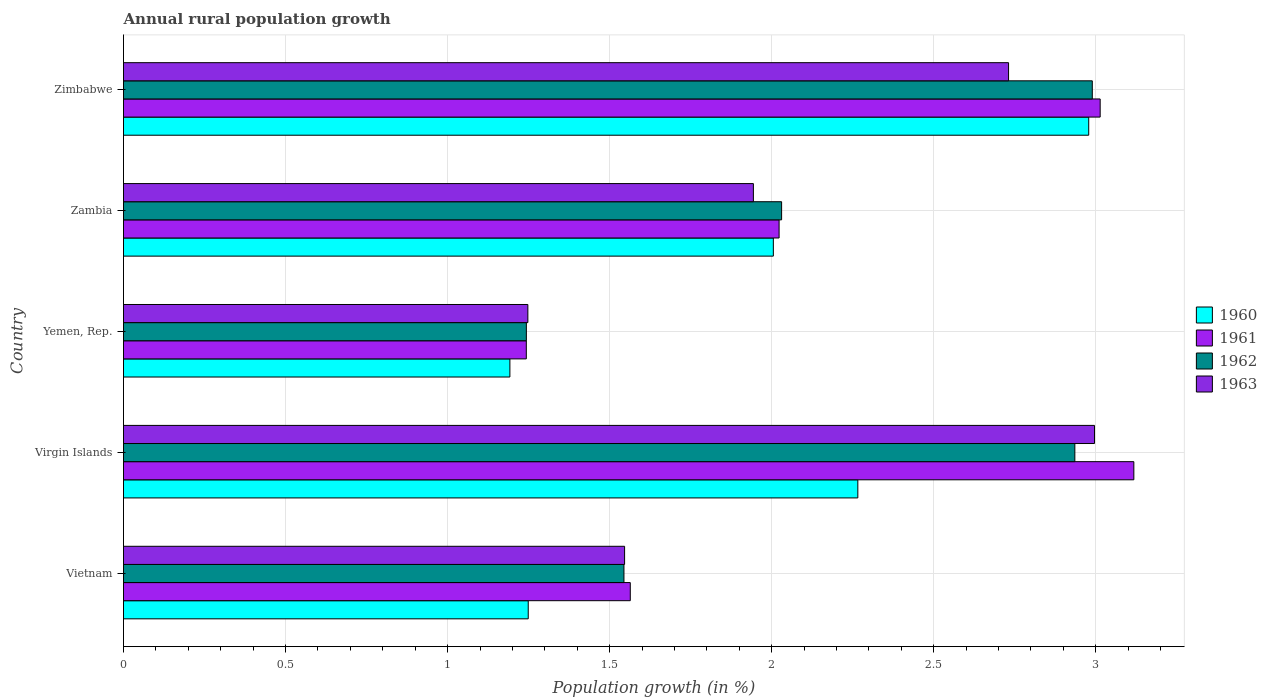How many groups of bars are there?
Provide a succinct answer. 5. Are the number of bars per tick equal to the number of legend labels?
Your answer should be very brief. Yes. Are the number of bars on each tick of the Y-axis equal?
Ensure brevity in your answer.  Yes. What is the label of the 2nd group of bars from the top?
Offer a terse response. Zambia. In how many cases, is the number of bars for a given country not equal to the number of legend labels?
Keep it short and to the point. 0. What is the percentage of rural population growth in 1961 in Zambia?
Offer a very short reply. 2.02. Across all countries, what is the maximum percentage of rural population growth in 1963?
Ensure brevity in your answer.  3. Across all countries, what is the minimum percentage of rural population growth in 1962?
Provide a succinct answer. 1.24. In which country was the percentage of rural population growth in 1962 maximum?
Ensure brevity in your answer.  Zimbabwe. In which country was the percentage of rural population growth in 1963 minimum?
Your answer should be compact. Yemen, Rep. What is the total percentage of rural population growth in 1962 in the graph?
Your answer should be compact. 10.74. What is the difference between the percentage of rural population growth in 1961 in Vietnam and that in Virgin Islands?
Give a very brief answer. -1.55. What is the difference between the percentage of rural population growth in 1960 in Yemen, Rep. and the percentage of rural population growth in 1961 in Zimbabwe?
Your response must be concise. -1.82. What is the average percentage of rural population growth in 1963 per country?
Provide a succinct answer. 2.09. What is the difference between the percentage of rural population growth in 1962 and percentage of rural population growth in 1960 in Yemen, Rep.?
Offer a terse response. 0.05. In how many countries, is the percentage of rural population growth in 1961 greater than 3.1 %?
Your answer should be very brief. 1. What is the ratio of the percentage of rural population growth in 1962 in Vietnam to that in Yemen, Rep.?
Offer a terse response. 1.24. Is the percentage of rural population growth in 1961 in Vietnam less than that in Zimbabwe?
Provide a short and direct response. Yes. What is the difference between the highest and the second highest percentage of rural population growth in 1960?
Give a very brief answer. 0.71. What is the difference between the highest and the lowest percentage of rural population growth in 1963?
Keep it short and to the point. 1.75. Is it the case that in every country, the sum of the percentage of rural population growth in 1960 and percentage of rural population growth in 1962 is greater than the sum of percentage of rural population growth in 1961 and percentage of rural population growth in 1963?
Offer a terse response. No. What does the 3rd bar from the top in Vietnam represents?
Your answer should be very brief. 1961. What does the 3rd bar from the bottom in Vietnam represents?
Ensure brevity in your answer.  1962. Is it the case that in every country, the sum of the percentage of rural population growth in 1962 and percentage of rural population growth in 1963 is greater than the percentage of rural population growth in 1961?
Your answer should be very brief. Yes. How many bars are there?
Offer a terse response. 20. How many countries are there in the graph?
Your answer should be compact. 5. Does the graph contain any zero values?
Your answer should be very brief. No. Does the graph contain grids?
Provide a succinct answer. Yes. How are the legend labels stacked?
Ensure brevity in your answer.  Vertical. What is the title of the graph?
Offer a terse response. Annual rural population growth. What is the label or title of the X-axis?
Keep it short and to the point. Population growth (in %). What is the Population growth (in %) in 1960 in Vietnam?
Make the answer very short. 1.25. What is the Population growth (in %) in 1961 in Vietnam?
Keep it short and to the point. 1.56. What is the Population growth (in %) in 1962 in Vietnam?
Make the answer very short. 1.54. What is the Population growth (in %) in 1963 in Vietnam?
Your answer should be very brief. 1.55. What is the Population growth (in %) in 1960 in Virgin Islands?
Your response must be concise. 2.27. What is the Population growth (in %) of 1961 in Virgin Islands?
Provide a short and direct response. 3.12. What is the Population growth (in %) in 1962 in Virgin Islands?
Your answer should be compact. 2.94. What is the Population growth (in %) of 1963 in Virgin Islands?
Ensure brevity in your answer.  3. What is the Population growth (in %) of 1960 in Yemen, Rep.?
Ensure brevity in your answer.  1.19. What is the Population growth (in %) in 1961 in Yemen, Rep.?
Your answer should be compact. 1.24. What is the Population growth (in %) in 1962 in Yemen, Rep.?
Ensure brevity in your answer.  1.24. What is the Population growth (in %) of 1963 in Yemen, Rep.?
Your answer should be compact. 1.25. What is the Population growth (in %) in 1960 in Zambia?
Provide a succinct answer. 2.01. What is the Population growth (in %) in 1961 in Zambia?
Offer a very short reply. 2.02. What is the Population growth (in %) in 1962 in Zambia?
Ensure brevity in your answer.  2.03. What is the Population growth (in %) in 1963 in Zambia?
Ensure brevity in your answer.  1.94. What is the Population growth (in %) of 1960 in Zimbabwe?
Give a very brief answer. 2.98. What is the Population growth (in %) in 1961 in Zimbabwe?
Offer a very short reply. 3.01. What is the Population growth (in %) in 1962 in Zimbabwe?
Keep it short and to the point. 2.99. What is the Population growth (in %) in 1963 in Zimbabwe?
Your answer should be compact. 2.73. Across all countries, what is the maximum Population growth (in %) of 1960?
Offer a very short reply. 2.98. Across all countries, what is the maximum Population growth (in %) of 1961?
Provide a succinct answer. 3.12. Across all countries, what is the maximum Population growth (in %) in 1962?
Provide a succinct answer. 2.99. Across all countries, what is the maximum Population growth (in %) of 1963?
Provide a short and direct response. 3. Across all countries, what is the minimum Population growth (in %) of 1960?
Your answer should be compact. 1.19. Across all countries, what is the minimum Population growth (in %) of 1961?
Your answer should be very brief. 1.24. Across all countries, what is the minimum Population growth (in %) in 1962?
Make the answer very short. 1.24. Across all countries, what is the minimum Population growth (in %) of 1963?
Make the answer very short. 1.25. What is the total Population growth (in %) in 1960 in the graph?
Offer a terse response. 9.69. What is the total Population growth (in %) in 1961 in the graph?
Provide a short and direct response. 10.96. What is the total Population growth (in %) of 1962 in the graph?
Make the answer very short. 10.74. What is the total Population growth (in %) in 1963 in the graph?
Make the answer very short. 10.46. What is the difference between the Population growth (in %) of 1960 in Vietnam and that in Virgin Islands?
Make the answer very short. -1.02. What is the difference between the Population growth (in %) of 1961 in Vietnam and that in Virgin Islands?
Provide a succinct answer. -1.55. What is the difference between the Population growth (in %) in 1962 in Vietnam and that in Virgin Islands?
Your response must be concise. -1.39. What is the difference between the Population growth (in %) of 1963 in Vietnam and that in Virgin Islands?
Provide a short and direct response. -1.45. What is the difference between the Population growth (in %) in 1960 in Vietnam and that in Yemen, Rep.?
Your response must be concise. 0.06. What is the difference between the Population growth (in %) of 1961 in Vietnam and that in Yemen, Rep.?
Offer a very short reply. 0.32. What is the difference between the Population growth (in %) in 1962 in Vietnam and that in Yemen, Rep.?
Keep it short and to the point. 0.3. What is the difference between the Population growth (in %) of 1963 in Vietnam and that in Yemen, Rep.?
Your answer should be compact. 0.3. What is the difference between the Population growth (in %) in 1960 in Vietnam and that in Zambia?
Ensure brevity in your answer.  -0.76. What is the difference between the Population growth (in %) in 1961 in Vietnam and that in Zambia?
Ensure brevity in your answer.  -0.46. What is the difference between the Population growth (in %) in 1962 in Vietnam and that in Zambia?
Give a very brief answer. -0.49. What is the difference between the Population growth (in %) of 1963 in Vietnam and that in Zambia?
Your response must be concise. -0.4. What is the difference between the Population growth (in %) in 1960 in Vietnam and that in Zimbabwe?
Provide a succinct answer. -1.73. What is the difference between the Population growth (in %) in 1961 in Vietnam and that in Zimbabwe?
Your response must be concise. -1.45. What is the difference between the Population growth (in %) of 1962 in Vietnam and that in Zimbabwe?
Ensure brevity in your answer.  -1.45. What is the difference between the Population growth (in %) of 1963 in Vietnam and that in Zimbabwe?
Your answer should be compact. -1.18. What is the difference between the Population growth (in %) in 1960 in Virgin Islands and that in Yemen, Rep.?
Provide a succinct answer. 1.07. What is the difference between the Population growth (in %) in 1961 in Virgin Islands and that in Yemen, Rep.?
Provide a short and direct response. 1.87. What is the difference between the Population growth (in %) in 1962 in Virgin Islands and that in Yemen, Rep.?
Your answer should be compact. 1.69. What is the difference between the Population growth (in %) of 1963 in Virgin Islands and that in Yemen, Rep.?
Keep it short and to the point. 1.75. What is the difference between the Population growth (in %) in 1960 in Virgin Islands and that in Zambia?
Ensure brevity in your answer.  0.26. What is the difference between the Population growth (in %) of 1961 in Virgin Islands and that in Zambia?
Your answer should be compact. 1.09. What is the difference between the Population growth (in %) of 1962 in Virgin Islands and that in Zambia?
Your answer should be compact. 0.9. What is the difference between the Population growth (in %) of 1963 in Virgin Islands and that in Zambia?
Your answer should be very brief. 1.05. What is the difference between the Population growth (in %) in 1960 in Virgin Islands and that in Zimbabwe?
Offer a terse response. -0.71. What is the difference between the Population growth (in %) in 1961 in Virgin Islands and that in Zimbabwe?
Give a very brief answer. 0.1. What is the difference between the Population growth (in %) in 1962 in Virgin Islands and that in Zimbabwe?
Make the answer very short. -0.05. What is the difference between the Population growth (in %) in 1963 in Virgin Islands and that in Zimbabwe?
Give a very brief answer. 0.27. What is the difference between the Population growth (in %) in 1960 in Yemen, Rep. and that in Zambia?
Give a very brief answer. -0.81. What is the difference between the Population growth (in %) in 1961 in Yemen, Rep. and that in Zambia?
Offer a very short reply. -0.78. What is the difference between the Population growth (in %) in 1962 in Yemen, Rep. and that in Zambia?
Give a very brief answer. -0.79. What is the difference between the Population growth (in %) of 1963 in Yemen, Rep. and that in Zambia?
Your answer should be very brief. -0.7. What is the difference between the Population growth (in %) of 1960 in Yemen, Rep. and that in Zimbabwe?
Your answer should be very brief. -1.79. What is the difference between the Population growth (in %) of 1961 in Yemen, Rep. and that in Zimbabwe?
Offer a terse response. -1.77. What is the difference between the Population growth (in %) of 1962 in Yemen, Rep. and that in Zimbabwe?
Your response must be concise. -1.75. What is the difference between the Population growth (in %) of 1963 in Yemen, Rep. and that in Zimbabwe?
Ensure brevity in your answer.  -1.48. What is the difference between the Population growth (in %) of 1960 in Zambia and that in Zimbabwe?
Your answer should be compact. -0.97. What is the difference between the Population growth (in %) of 1961 in Zambia and that in Zimbabwe?
Make the answer very short. -0.99. What is the difference between the Population growth (in %) of 1962 in Zambia and that in Zimbabwe?
Make the answer very short. -0.96. What is the difference between the Population growth (in %) of 1963 in Zambia and that in Zimbabwe?
Your response must be concise. -0.79. What is the difference between the Population growth (in %) in 1960 in Vietnam and the Population growth (in %) in 1961 in Virgin Islands?
Make the answer very short. -1.87. What is the difference between the Population growth (in %) of 1960 in Vietnam and the Population growth (in %) of 1962 in Virgin Islands?
Your response must be concise. -1.69. What is the difference between the Population growth (in %) of 1960 in Vietnam and the Population growth (in %) of 1963 in Virgin Islands?
Give a very brief answer. -1.75. What is the difference between the Population growth (in %) of 1961 in Vietnam and the Population growth (in %) of 1962 in Virgin Islands?
Provide a succinct answer. -1.37. What is the difference between the Population growth (in %) of 1961 in Vietnam and the Population growth (in %) of 1963 in Virgin Islands?
Offer a very short reply. -1.43. What is the difference between the Population growth (in %) in 1962 in Vietnam and the Population growth (in %) in 1963 in Virgin Islands?
Provide a short and direct response. -1.45. What is the difference between the Population growth (in %) of 1960 in Vietnam and the Population growth (in %) of 1961 in Yemen, Rep.?
Your answer should be compact. 0.01. What is the difference between the Population growth (in %) in 1960 in Vietnam and the Population growth (in %) in 1962 in Yemen, Rep.?
Provide a succinct answer. 0.01. What is the difference between the Population growth (in %) of 1960 in Vietnam and the Population growth (in %) of 1963 in Yemen, Rep.?
Your answer should be very brief. 0. What is the difference between the Population growth (in %) in 1961 in Vietnam and the Population growth (in %) in 1962 in Yemen, Rep.?
Give a very brief answer. 0.32. What is the difference between the Population growth (in %) of 1961 in Vietnam and the Population growth (in %) of 1963 in Yemen, Rep.?
Your answer should be compact. 0.32. What is the difference between the Population growth (in %) of 1962 in Vietnam and the Population growth (in %) of 1963 in Yemen, Rep.?
Your response must be concise. 0.3. What is the difference between the Population growth (in %) in 1960 in Vietnam and the Population growth (in %) in 1961 in Zambia?
Provide a short and direct response. -0.77. What is the difference between the Population growth (in %) of 1960 in Vietnam and the Population growth (in %) of 1962 in Zambia?
Provide a short and direct response. -0.78. What is the difference between the Population growth (in %) of 1960 in Vietnam and the Population growth (in %) of 1963 in Zambia?
Your response must be concise. -0.69. What is the difference between the Population growth (in %) in 1961 in Vietnam and the Population growth (in %) in 1962 in Zambia?
Offer a terse response. -0.47. What is the difference between the Population growth (in %) in 1961 in Vietnam and the Population growth (in %) in 1963 in Zambia?
Your answer should be very brief. -0.38. What is the difference between the Population growth (in %) in 1962 in Vietnam and the Population growth (in %) in 1963 in Zambia?
Your answer should be very brief. -0.4. What is the difference between the Population growth (in %) of 1960 in Vietnam and the Population growth (in %) of 1961 in Zimbabwe?
Provide a succinct answer. -1.76. What is the difference between the Population growth (in %) in 1960 in Vietnam and the Population growth (in %) in 1962 in Zimbabwe?
Offer a terse response. -1.74. What is the difference between the Population growth (in %) of 1960 in Vietnam and the Population growth (in %) of 1963 in Zimbabwe?
Provide a succinct answer. -1.48. What is the difference between the Population growth (in %) of 1961 in Vietnam and the Population growth (in %) of 1962 in Zimbabwe?
Keep it short and to the point. -1.43. What is the difference between the Population growth (in %) of 1961 in Vietnam and the Population growth (in %) of 1963 in Zimbabwe?
Your answer should be compact. -1.17. What is the difference between the Population growth (in %) in 1962 in Vietnam and the Population growth (in %) in 1963 in Zimbabwe?
Ensure brevity in your answer.  -1.19. What is the difference between the Population growth (in %) in 1960 in Virgin Islands and the Population growth (in %) in 1961 in Yemen, Rep.?
Ensure brevity in your answer.  1.02. What is the difference between the Population growth (in %) in 1960 in Virgin Islands and the Population growth (in %) in 1962 in Yemen, Rep.?
Ensure brevity in your answer.  1.02. What is the difference between the Population growth (in %) in 1960 in Virgin Islands and the Population growth (in %) in 1963 in Yemen, Rep.?
Keep it short and to the point. 1.02. What is the difference between the Population growth (in %) of 1961 in Virgin Islands and the Population growth (in %) of 1962 in Yemen, Rep.?
Keep it short and to the point. 1.87. What is the difference between the Population growth (in %) in 1961 in Virgin Islands and the Population growth (in %) in 1963 in Yemen, Rep.?
Ensure brevity in your answer.  1.87. What is the difference between the Population growth (in %) in 1962 in Virgin Islands and the Population growth (in %) in 1963 in Yemen, Rep.?
Ensure brevity in your answer.  1.69. What is the difference between the Population growth (in %) in 1960 in Virgin Islands and the Population growth (in %) in 1961 in Zambia?
Keep it short and to the point. 0.24. What is the difference between the Population growth (in %) in 1960 in Virgin Islands and the Population growth (in %) in 1962 in Zambia?
Provide a short and direct response. 0.24. What is the difference between the Population growth (in %) of 1960 in Virgin Islands and the Population growth (in %) of 1963 in Zambia?
Ensure brevity in your answer.  0.32. What is the difference between the Population growth (in %) of 1961 in Virgin Islands and the Population growth (in %) of 1962 in Zambia?
Your answer should be very brief. 1.09. What is the difference between the Population growth (in %) in 1961 in Virgin Islands and the Population growth (in %) in 1963 in Zambia?
Ensure brevity in your answer.  1.17. What is the difference between the Population growth (in %) of 1962 in Virgin Islands and the Population growth (in %) of 1963 in Zambia?
Offer a very short reply. 0.99. What is the difference between the Population growth (in %) in 1960 in Virgin Islands and the Population growth (in %) in 1961 in Zimbabwe?
Provide a short and direct response. -0.75. What is the difference between the Population growth (in %) in 1960 in Virgin Islands and the Population growth (in %) in 1962 in Zimbabwe?
Provide a short and direct response. -0.72. What is the difference between the Population growth (in %) in 1960 in Virgin Islands and the Population growth (in %) in 1963 in Zimbabwe?
Ensure brevity in your answer.  -0.47. What is the difference between the Population growth (in %) in 1961 in Virgin Islands and the Population growth (in %) in 1962 in Zimbabwe?
Provide a succinct answer. 0.13. What is the difference between the Population growth (in %) in 1961 in Virgin Islands and the Population growth (in %) in 1963 in Zimbabwe?
Your answer should be very brief. 0.39. What is the difference between the Population growth (in %) in 1962 in Virgin Islands and the Population growth (in %) in 1963 in Zimbabwe?
Your answer should be very brief. 0.2. What is the difference between the Population growth (in %) in 1960 in Yemen, Rep. and the Population growth (in %) in 1961 in Zambia?
Give a very brief answer. -0.83. What is the difference between the Population growth (in %) of 1960 in Yemen, Rep. and the Population growth (in %) of 1962 in Zambia?
Your answer should be very brief. -0.84. What is the difference between the Population growth (in %) of 1960 in Yemen, Rep. and the Population growth (in %) of 1963 in Zambia?
Keep it short and to the point. -0.75. What is the difference between the Population growth (in %) of 1961 in Yemen, Rep. and the Population growth (in %) of 1962 in Zambia?
Your answer should be compact. -0.79. What is the difference between the Population growth (in %) in 1961 in Yemen, Rep. and the Population growth (in %) in 1963 in Zambia?
Give a very brief answer. -0.7. What is the difference between the Population growth (in %) in 1962 in Yemen, Rep. and the Population growth (in %) in 1963 in Zambia?
Give a very brief answer. -0.7. What is the difference between the Population growth (in %) of 1960 in Yemen, Rep. and the Population growth (in %) of 1961 in Zimbabwe?
Offer a very short reply. -1.82. What is the difference between the Population growth (in %) in 1960 in Yemen, Rep. and the Population growth (in %) in 1962 in Zimbabwe?
Offer a terse response. -1.8. What is the difference between the Population growth (in %) of 1960 in Yemen, Rep. and the Population growth (in %) of 1963 in Zimbabwe?
Provide a short and direct response. -1.54. What is the difference between the Population growth (in %) in 1961 in Yemen, Rep. and the Population growth (in %) in 1962 in Zimbabwe?
Provide a short and direct response. -1.75. What is the difference between the Population growth (in %) of 1961 in Yemen, Rep. and the Population growth (in %) of 1963 in Zimbabwe?
Make the answer very short. -1.49. What is the difference between the Population growth (in %) in 1962 in Yemen, Rep. and the Population growth (in %) in 1963 in Zimbabwe?
Make the answer very short. -1.49. What is the difference between the Population growth (in %) of 1960 in Zambia and the Population growth (in %) of 1961 in Zimbabwe?
Provide a short and direct response. -1.01. What is the difference between the Population growth (in %) in 1960 in Zambia and the Population growth (in %) in 1962 in Zimbabwe?
Give a very brief answer. -0.98. What is the difference between the Population growth (in %) of 1960 in Zambia and the Population growth (in %) of 1963 in Zimbabwe?
Your answer should be compact. -0.73. What is the difference between the Population growth (in %) of 1961 in Zambia and the Population growth (in %) of 1962 in Zimbabwe?
Keep it short and to the point. -0.97. What is the difference between the Population growth (in %) of 1961 in Zambia and the Population growth (in %) of 1963 in Zimbabwe?
Make the answer very short. -0.71. What is the difference between the Population growth (in %) in 1962 in Zambia and the Population growth (in %) in 1963 in Zimbabwe?
Your answer should be very brief. -0.7. What is the average Population growth (in %) of 1960 per country?
Make the answer very short. 1.94. What is the average Population growth (in %) in 1961 per country?
Give a very brief answer. 2.19. What is the average Population growth (in %) in 1962 per country?
Your answer should be compact. 2.15. What is the average Population growth (in %) in 1963 per country?
Ensure brevity in your answer.  2.09. What is the difference between the Population growth (in %) in 1960 and Population growth (in %) in 1961 in Vietnam?
Your response must be concise. -0.31. What is the difference between the Population growth (in %) in 1960 and Population growth (in %) in 1962 in Vietnam?
Your response must be concise. -0.3. What is the difference between the Population growth (in %) in 1960 and Population growth (in %) in 1963 in Vietnam?
Give a very brief answer. -0.3. What is the difference between the Population growth (in %) of 1961 and Population growth (in %) of 1962 in Vietnam?
Make the answer very short. 0.02. What is the difference between the Population growth (in %) in 1961 and Population growth (in %) in 1963 in Vietnam?
Make the answer very short. 0.02. What is the difference between the Population growth (in %) in 1962 and Population growth (in %) in 1963 in Vietnam?
Offer a very short reply. -0. What is the difference between the Population growth (in %) of 1960 and Population growth (in %) of 1961 in Virgin Islands?
Provide a short and direct response. -0.85. What is the difference between the Population growth (in %) in 1960 and Population growth (in %) in 1962 in Virgin Islands?
Keep it short and to the point. -0.67. What is the difference between the Population growth (in %) in 1960 and Population growth (in %) in 1963 in Virgin Islands?
Give a very brief answer. -0.73. What is the difference between the Population growth (in %) in 1961 and Population growth (in %) in 1962 in Virgin Islands?
Keep it short and to the point. 0.18. What is the difference between the Population growth (in %) in 1961 and Population growth (in %) in 1963 in Virgin Islands?
Ensure brevity in your answer.  0.12. What is the difference between the Population growth (in %) of 1962 and Population growth (in %) of 1963 in Virgin Islands?
Your answer should be compact. -0.06. What is the difference between the Population growth (in %) of 1960 and Population growth (in %) of 1961 in Yemen, Rep.?
Provide a succinct answer. -0.05. What is the difference between the Population growth (in %) in 1960 and Population growth (in %) in 1962 in Yemen, Rep.?
Your answer should be very brief. -0.05. What is the difference between the Population growth (in %) in 1960 and Population growth (in %) in 1963 in Yemen, Rep.?
Keep it short and to the point. -0.06. What is the difference between the Population growth (in %) in 1961 and Population growth (in %) in 1962 in Yemen, Rep.?
Your response must be concise. -0. What is the difference between the Population growth (in %) in 1961 and Population growth (in %) in 1963 in Yemen, Rep.?
Offer a terse response. -0. What is the difference between the Population growth (in %) of 1962 and Population growth (in %) of 1963 in Yemen, Rep.?
Your answer should be compact. -0. What is the difference between the Population growth (in %) of 1960 and Population growth (in %) of 1961 in Zambia?
Make the answer very short. -0.02. What is the difference between the Population growth (in %) in 1960 and Population growth (in %) in 1962 in Zambia?
Your response must be concise. -0.03. What is the difference between the Population growth (in %) in 1960 and Population growth (in %) in 1963 in Zambia?
Your response must be concise. 0.06. What is the difference between the Population growth (in %) in 1961 and Population growth (in %) in 1962 in Zambia?
Ensure brevity in your answer.  -0.01. What is the difference between the Population growth (in %) in 1961 and Population growth (in %) in 1963 in Zambia?
Give a very brief answer. 0.08. What is the difference between the Population growth (in %) of 1962 and Population growth (in %) of 1963 in Zambia?
Make the answer very short. 0.09. What is the difference between the Population growth (in %) of 1960 and Population growth (in %) of 1961 in Zimbabwe?
Your response must be concise. -0.04. What is the difference between the Population growth (in %) of 1960 and Population growth (in %) of 1962 in Zimbabwe?
Offer a very short reply. -0.01. What is the difference between the Population growth (in %) in 1960 and Population growth (in %) in 1963 in Zimbabwe?
Make the answer very short. 0.25. What is the difference between the Population growth (in %) of 1961 and Population growth (in %) of 1962 in Zimbabwe?
Offer a very short reply. 0.02. What is the difference between the Population growth (in %) of 1961 and Population growth (in %) of 1963 in Zimbabwe?
Give a very brief answer. 0.28. What is the difference between the Population growth (in %) of 1962 and Population growth (in %) of 1963 in Zimbabwe?
Your answer should be very brief. 0.26. What is the ratio of the Population growth (in %) in 1960 in Vietnam to that in Virgin Islands?
Offer a very short reply. 0.55. What is the ratio of the Population growth (in %) of 1961 in Vietnam to that in Virgin Islands?
Your answer should be compact. 0.5. What is the ratio of the Population growth (in %) of 1962 in Vietnam to that in Virgin Islands?
Keep it short and to the point. 0.53. What is the ratio of the Population growth (in %) in 1963 in Vietnam to that in Virgin Islands?
Offer a very short reply. 0.52. What is the ratio of the Population growth (in %) in 1960 in Vietnam to that in Yemen, Rep.?
Ensure brevity in your answer.  1.05. What is the ratio of the Population growth (in %) in 1961 in Vietnam to that in Yemen, Rep.?
Keep it short and to the point. 1.26. What is the ratio of the Population growth (in %) of 1962 in Vietnam to that in Yemen, Rep.?
Your response must be concise. 1.24. What is the ratio of the Population growth (in %) in 1963 in Vietnam to that in Yemen, Rep.?
Provide a succinct answer. 1.24. What is the ratio of the Population growth (in %) of 1960 in Vietnam to that in Zambia?
Offer a terse response. 0.62. What is the ratio of the Population growth (in %) of 1961 in Vietnam to that in Zambia?
Provide a succinct answer. 0.77. What is the ratio of the Population growth (in %) in 1962 in Vietnam to that in Zambia?
Offer a terse response. 0.76. What is the ratio of the Population growth (in %) in 1963 in Vietnam to that in Zambia?
Keep it short and to the point. 0.8. What is the ratio of the Population growth (in %) of 1960 in Vietnam to that in Zimbabwe?
Offer a terse response. 0.42. What is the ratio of the Population growth (in %) in 1961 in Vietnam to that in Zimbabwe?
Give a very brief answer. 0.52. What is the ratio of the Population growth (in %) of 1962 in Vietnam to that in Zimbabwe?
Make the answer very short. 0.52. What is the ratio of the Population growth (in %) of 1963 in Vietnam to that in Zimbabwe?
Make the answer very short. 0.57. What is the ratio of the Population growth (in %) in 1960 in Virgin Islands to that in Yemen, Rep.?
Provide a succinct answer. 1.9. What is the ratio of the Population growth (in %) of 1961 in Virgin Islands to that in Yemen, Rep.?
Your response must be concise. 2.51. What is the ratio of the Population growth (in %) in 1962 in Virgin Islands to that in Yemen, Rep.?
Offer a very short reply. 2.36. What is the ratio of the Population growth (in %) in 1963 in Virgin Islands to that in Yemen, Rep.?
Your answer should be compact. 2.4. What is the ratio of the Population growth (in %) in 1960 in Virgin Islands to that in Zambia?
Ensure brevity in your answer.  1.13. What is the ratio of the Population growth (in %) of 1961 in Virgin Islands to that in Zambia?
Make the answer very short. 1.54. What is the ratio of the Population growth (in %) of 1962 in Virgin Islands to that in Zambia?
Give a very brief answer. 1.45. What is the ratio of the Population growth (in %) of 1963 in Virgin Islands to that in Zambia?
Provide a short and direct response. 1.54. What is the ratio of the Population growth (in %) in 1960 in Virgin Islands to that in Zimbabwe?
Give a very brief answer. 0.76. What is the ratio of the Population growth (in %) of 1961 in Virgin Islands to that in Zimbabwe?
Give a very brief answer. 1.03. What is the ratio of the Population growth (in %) of 1962 in Virgin Islands to that in Zimbabwe?
Your answer should be very brief. 0.98. What is the ratio of the Population growth (in %) of 1963 in Virgin Islands to that in Zimbabwe?
Make the answer very short. 1.1. What is the ratio of the Population growth (in %) of 1960 in Yemen, Rep. to that in Zambia?
Your answer should be very brief. 0.59. What is the ratio of the Population growth (in %) in 1961 in Yemen, Rep. to that in Zambia?
Your answer should be very brief. 0.61. What is the ratio of the Population growth (in %) of 1962 in Yemen, Rep. to that in Zambia?
Provide a succinct answer. 0.61. What is the ratio of the Population growth (in %) in 1963 in Yemen, Rep. to that in Zambia?
Offer a very short reply. 0.64. What is the ratio of the Population growth (in %) in 1960 in Yemen, Rep. to that in Zimbabwe?
Ensure brevity in your answer.  0.4. What is the ratio of the Population growth (in %) in 1961 in Yemen, Rep. to that in Zimbabwe?
Provide a succinct answer. 0.41. What is the ratio of the Population growth (in %) in 1962 in Yemen, Rep. to that in Zimbabwe?
Your response must be concise. 0.42. What is the ratio of the Population growth (in %) of 1963 in Yemen, Rep. to that in Zimbabwe?
Ensure brevity in your answer.  0.46. What is the ratio of the Population growth (in %) of 1960 in Zambia to that in Zimbabwe?
Ensure brevity in your answer.  0.67. What is the ratio of the Population growth (in %) of 1961 in Zambia to that in Zimbabwe?
Your answer should be very brief. 0.67. What is the ratio of the Population growth (in %) of 1962 in Zambia to that in Zimbabwe?
Keep it short and to the point. 0.68. What is the ratio of the Population growth (in %) in 1963 in Zambia to that in Zimbabwe?
Your response must be concise. 0.71. What is the difference between the highest and the second highest Population growth (in %) in 1960?
Your answer should be compact. 0.71. What is the difference between the highest and the second highest Population growth (in %) in 1961?
Your answer should be very brief. 0.1. What is the difference between the highest and the second highest Population growth (in %) in 1962?
Your answer should be compact. 0.05. What is the difference between the highest and the second highest Population growth (in %) of 1963?
Your answer should be compact. 0.27. What is the difference between the highest and the lowest Population growth (in %) in 1960?
Offer a very short reply. 1.79. What is the difference between the highest and the lowest Population growth (in %) in 1961?
Your answer should be compact. 1.87. What is the difference between the highest and the lowest Population growth (in %) in 1962?
Make the answer very short. 1.75. What is the difference between the highest and the lowest Population growth (in %) in 1963?
Keep it short and to the point. 1.75. 